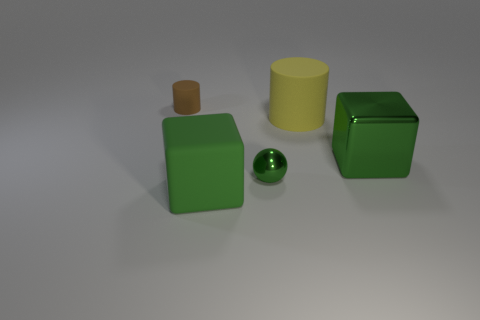There is a green cube behind the sphere; what is it made of?
Keep it short and to the point. Metal. The tiny thing that is behind the big green object behind the block that is in front of the tiny shiny object is what shape?
Offer a terse response. Cylinder. There is a metal object that is behind the green ball; is its color the same as the large thing that is in front of the metallic sphere?
Ensure brevity in your answer.  Yes. Is the number of small matte objects that are behind the tiny cylinder less than the number of green metallic blocks left of the small green metallic thing?
Offer a very short reply. No. Is there anything else that has the same shape as the tiny green shiny thing?
Your answer should be compact. No. There is another matte thing that is the same shape as the small brown thing; what is its color?
Make the answer very short. Yellow. Do the big yellow object and the rubber thing that is left of the green matte block have the same shape?
Give a very brief answer. Yes. What number of objects are big green things to the right of the large yellow rubber cylinder or big blocks that are on the right side of the yellow object?
Ensure brevity in your answer.  1. What material is the small cylinder?
Your answer should be compact. Rubber. What number of other things are there of the same size as the ball?
Provide a succinct answer. 1. 